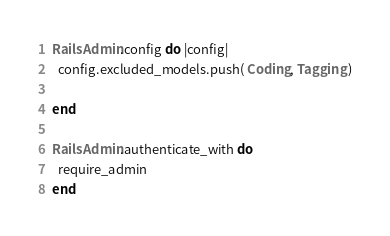<code> <loc_0><loc_0><loc_500><loc_500><_Ruby_>RailsAdmin.config do |config|
  config.excluded_models.push( Coding, Tagging )

end

RailsAdmin.authenticate_with do
  require_admin
end
</code> 